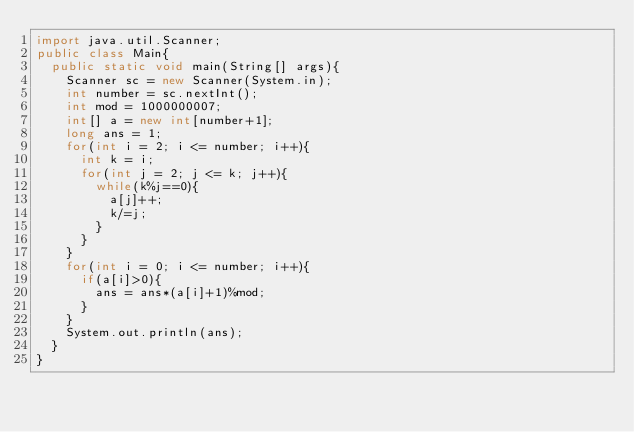Convert code to text. <code><loc_0><loc_0><loc_500><loc_500><_Java_>import java.util.Scanner;
public class Main{
	public static void main(String[] args){
		Scanner sc = new Scanner(System.in);
		int number = sc.nextInt();
		int mod = 1000000007;
		int[] a = new int[number+1];
		long ans = 1;
		for(int i = 2; i <= number; i++){
			int k = i;
			for(int j = 2; j <= k; j++){
				while(k%j==0){
					a[j]++;
					k/=j;
				}
			}
		}
		for(int i = 0; i <= number; i++){
			if(a[i]>0){
				ans = ans*(a[i]+1)%mod;
			}
		}
		System.out.println(ans);
	}
}</code> 